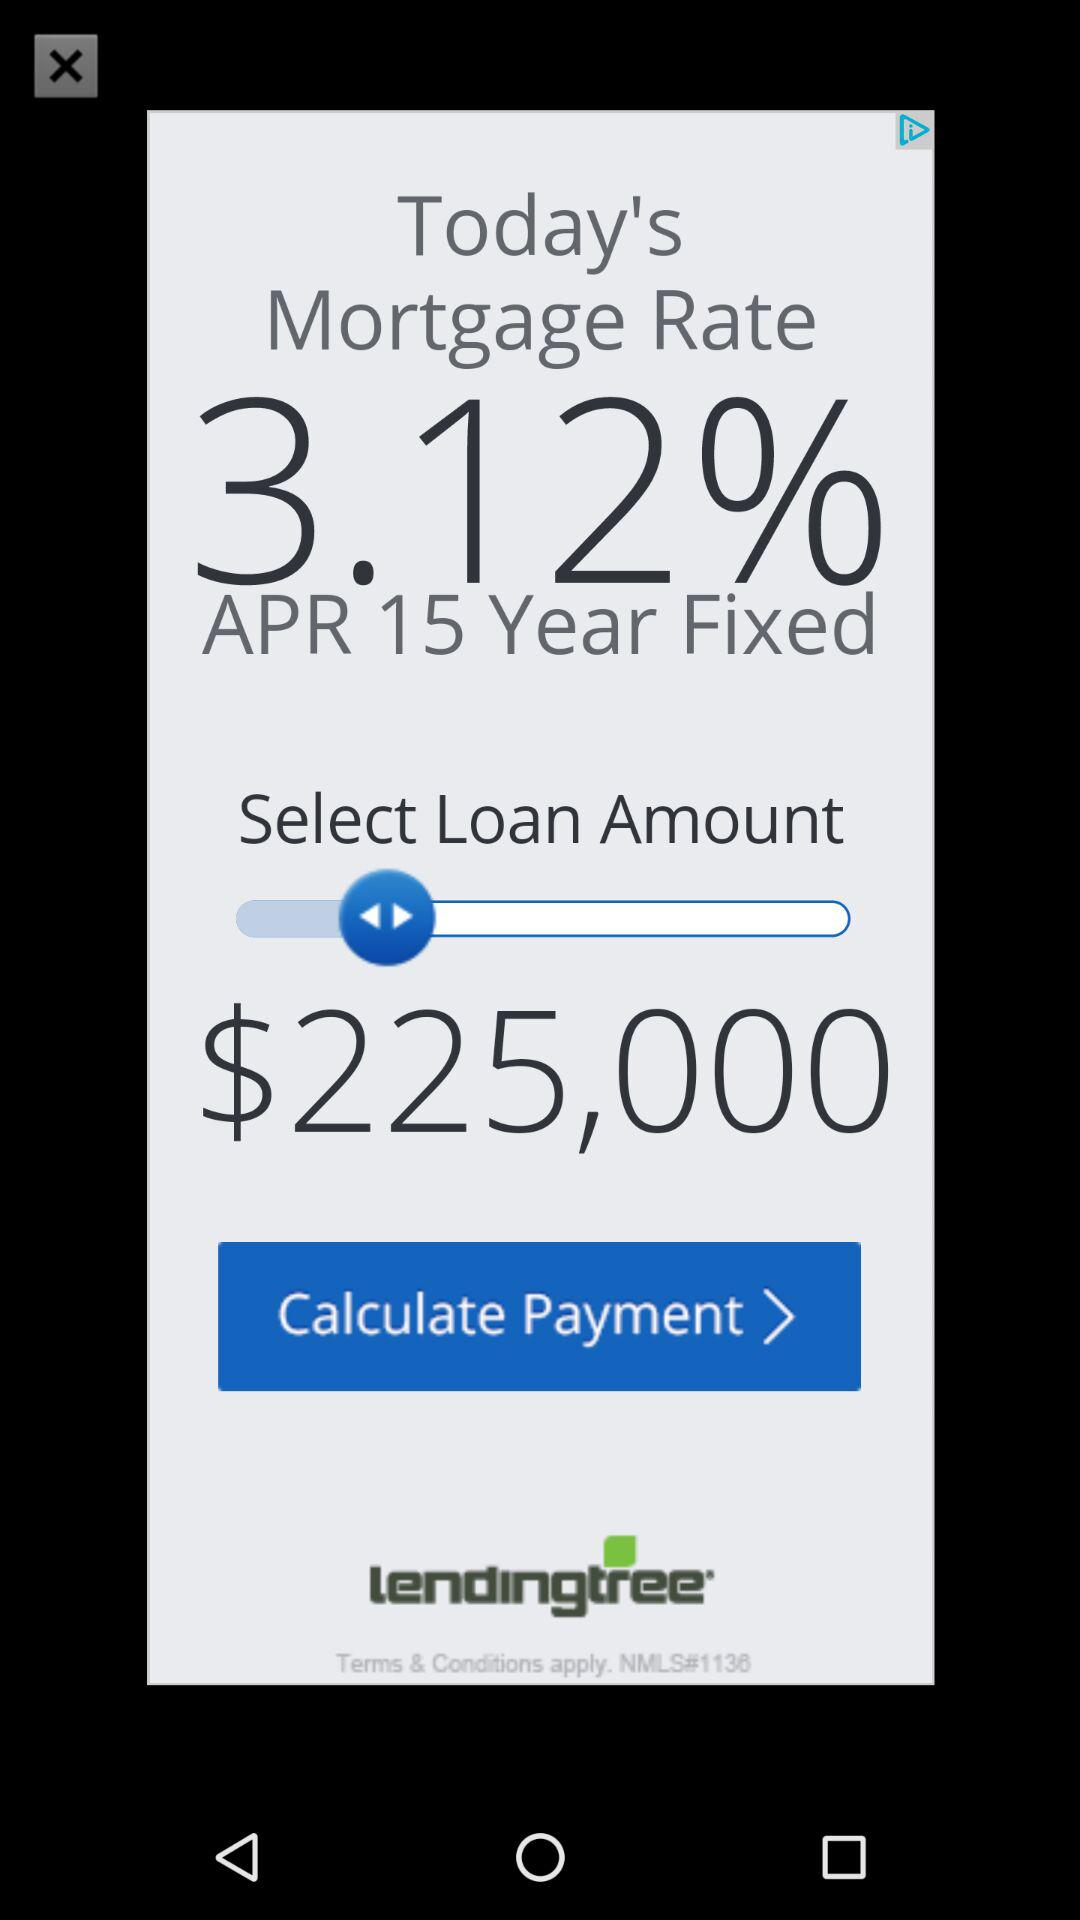How many payments until the loan is paid off?
When the provided information is insufficient, respond with <no answer>. <no answer> 